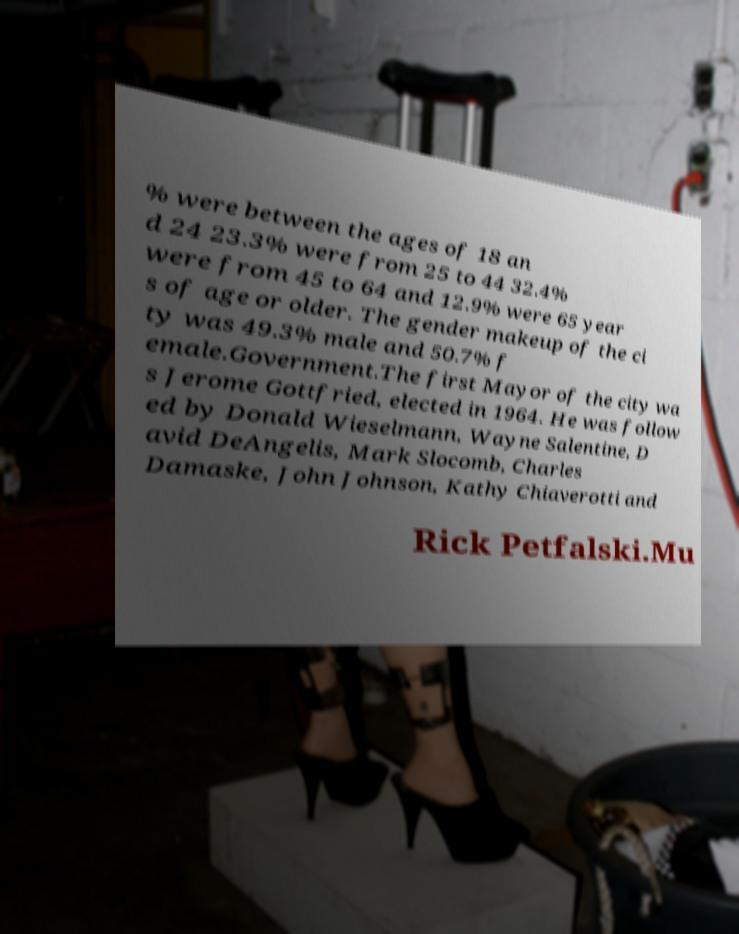For documentation purposes, I need the text within this image transcribed. Could you provide that? % were between the ages of 18 an d 24 23.3% were from 25 to 44 32.4% were from 45 to 64 and 12.9% were 65 year s of age or older. The gender makeup of the ci ty was 49.3% male and 50.7% f emale.Government.The first Mayor of the city wa s Jerome Gottfried, elected in 1964. He was follow ed by Donald Wieselmann, Wayne Salentine, D avid DeAngelis, Mark Slocomb, Charles Damaske, John Johnson, Kathy Chiaverotti and Rick Petfalski.Mu 